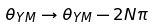Convert formula to latex. <formula><loc_0><loc_0><loc_500><loc_500>\theta _ { Y M } \rightarrow \theta _ { Y M } - 2 N \pi</formula> 